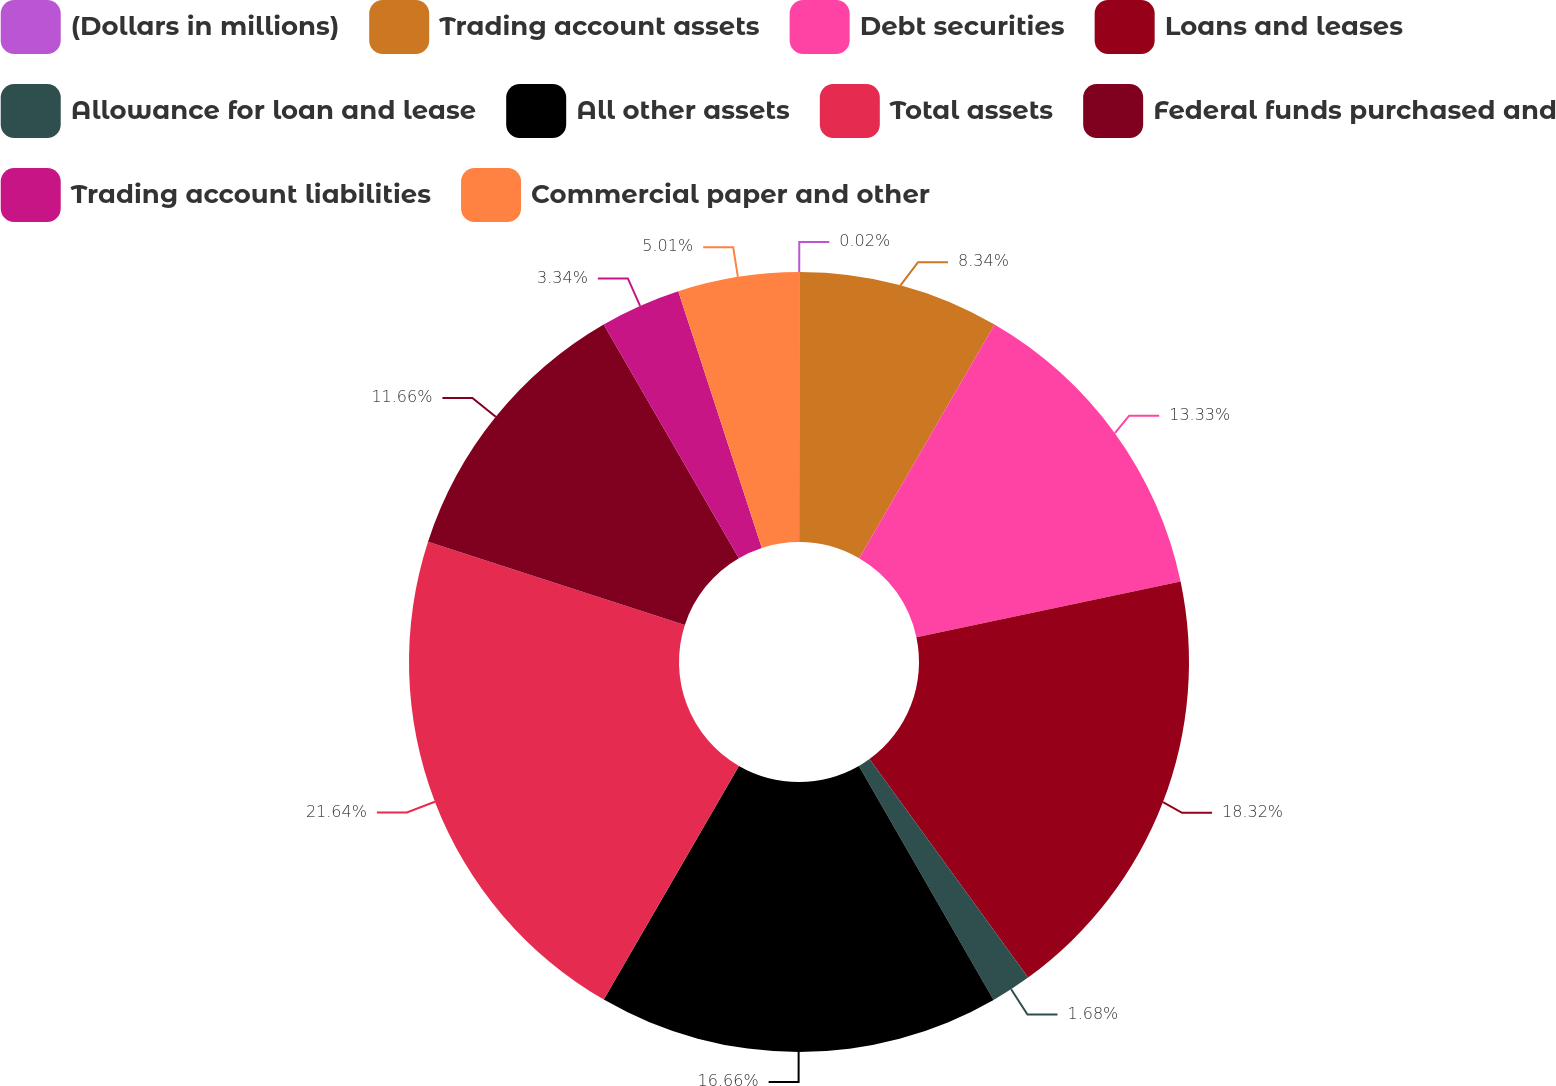<chart> <loc_0><loc_0><loc_500><loc_500><pie_chart><fcel>(Dollars in millions)<fcel>Trading account assets<fcel>Debt securities<fcel>Loans and leases<fcel>Allowance for loan and lease<fcel>All other assets<fcel>Total assets<fcel>Federal funds purchased and<fcel>Trading account liabilities<fcel>Commercial paper and other<nl><fcel>0.02%<fcel>8.34%<fcel>13.33%<fcel>18.32%<fcel>1.68%<fcel>16.66%<fcel>21.65%<fcel>11.66%<fcel>3.34%<fcel>5.01%<nl></chart> 